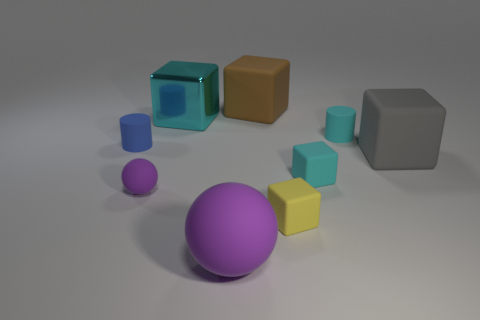Subtract all gray balls. How many cyan cubes are left? 2 Subtract all large metallic blocks. How many blocks are left? 4 Subtract all brown blocks. How many blocks are left? 4 Subtract all blue blocks. Subtract all purple spheres. How many blocks are left? 5 Subtract all cubes. How many objects are left? 4 Subtract all tiny blue things. Subtract all cyan objects. How many objects are left? 5 Add 2 metallic cubes. How many metallic cubes are left? 3 Add 4 small purple things. How many small purple things exist? 5 Subtract 1 cyan cylinders. How many objects are left? 8 